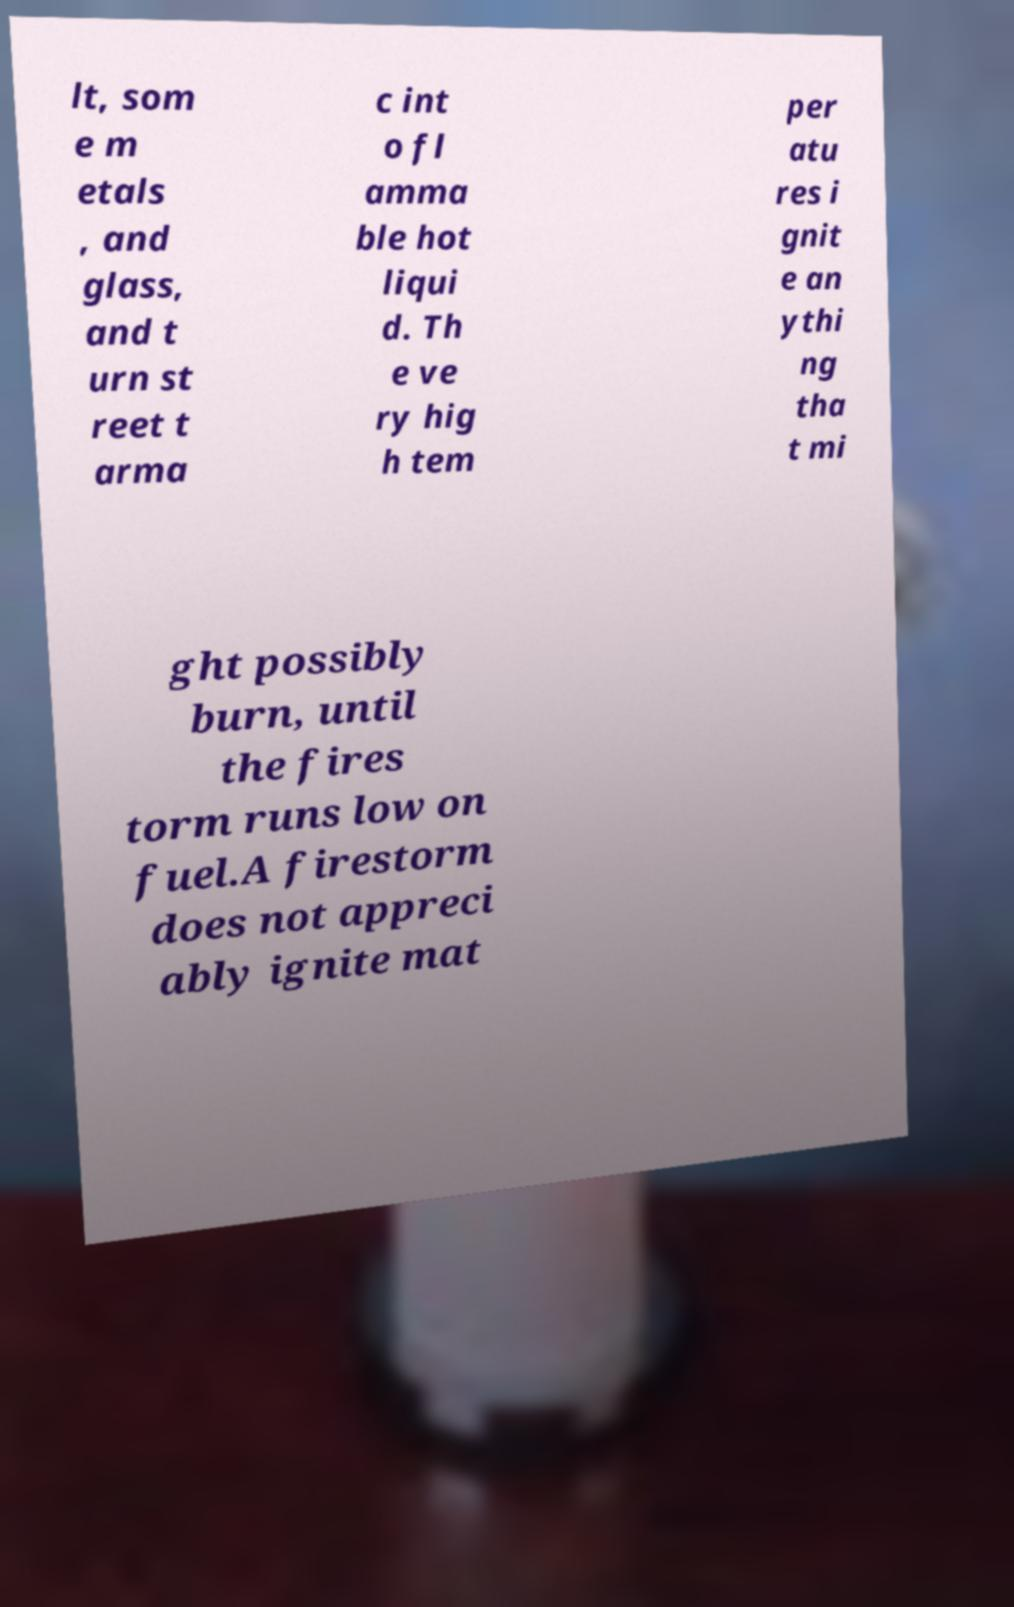I need the written content from this picture converted into text. Can you do that? lt, som e m etals , and glass, and t urn st reet t arma c int o fl amma ble hot liqui d. Th e ve ry hig h tem per atu res i gnit e an ythi ng tha t mi ght possibly burn, until the fires torm runs low on fuel.A firestorm does not appreci ably ignite mat 